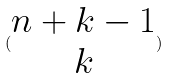Convert formula to latex. <formula><loc_0><loc_0><loc_500><loc_500>( \begin{matrix} n + k - 1 \\ k \end{matrix} )</formula> 